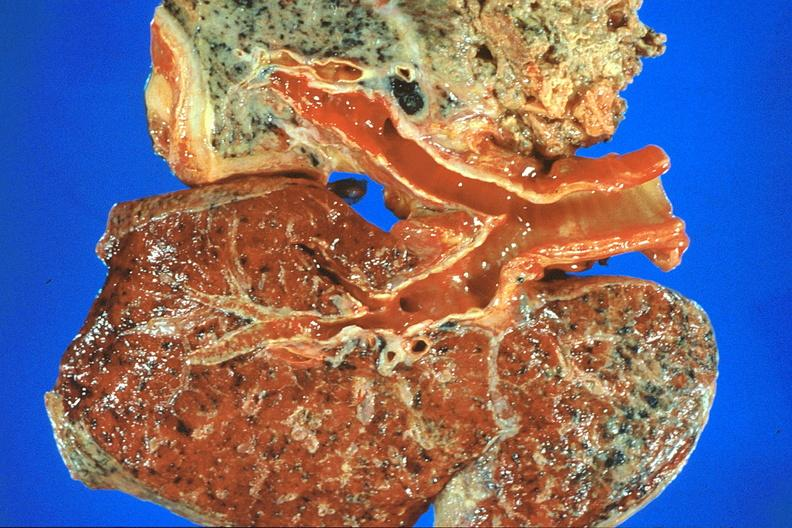what does this image show?
Answer the question using a single word or phrase. Lung 